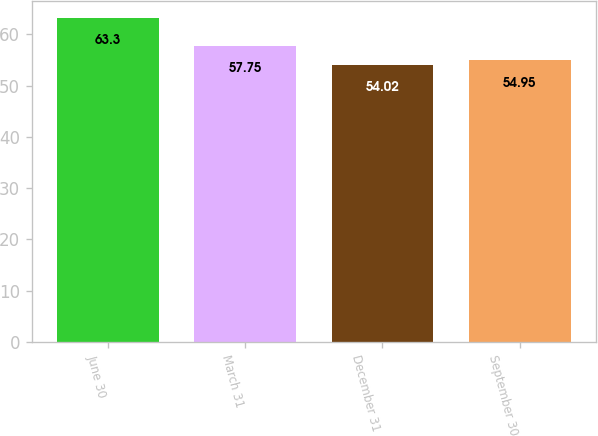Convert chart. <chart><loc_0><loc_0><loc_500><loc_500><bar_chart><fcel>June 30<fcel>March 31<fcel>December 31<fcel>September 30<nl><fcel>63.3<fcel>57.75<fcel>54.02<fcel>54.95<nl></chart> 